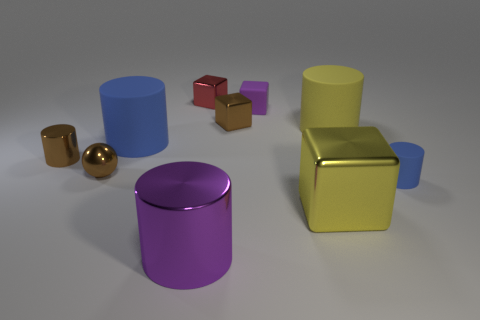Subtract 2 cubes. How many cubes are left? 2 Subtract all metal cubes. How many cubes are left? 1 Subtract all purple cylinders. How many cylinders are left? 4 Subtract all blue blocks. Subtract all brown balls. How many blocks are left? 4 Subtract all blocks. How many objects are left? 6 Subtract all purple rubber balls. Subtract all large cylinders. How many objects are left? 7 Add 5 big metallic things. How many big metallic things are left? 7 Add 8 large blocks. How many large blocks exist? 9 Subtract 0 cyan balls. How many objects are left? 10 